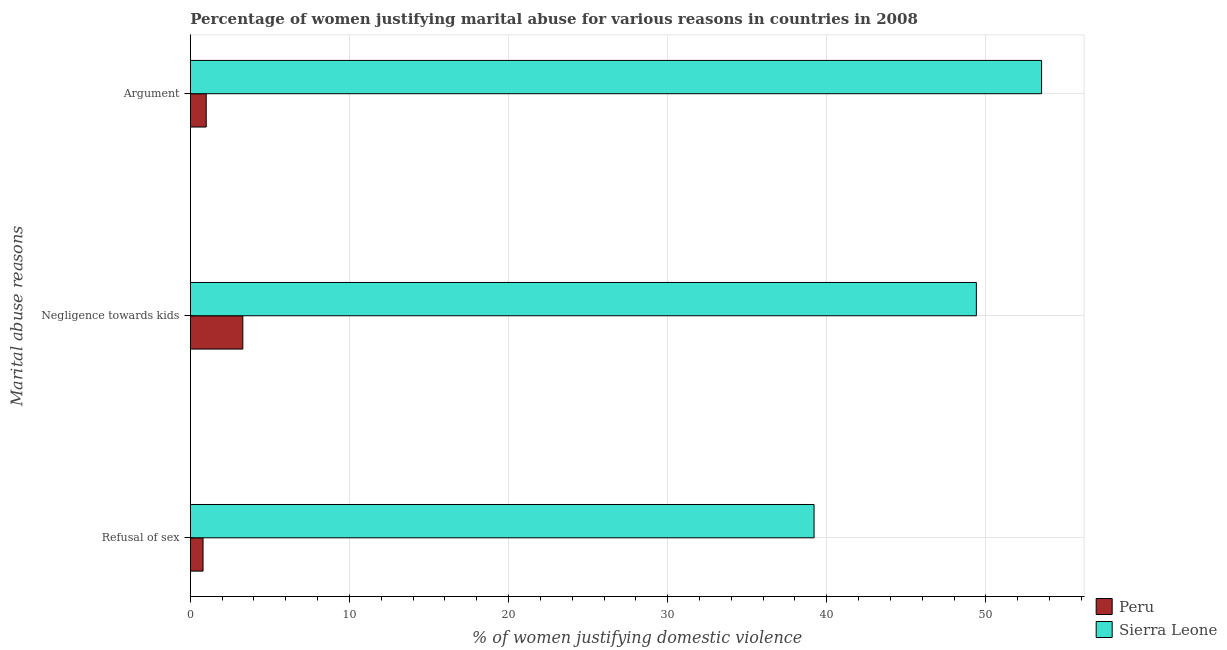What is the label of the 3rd group of bars from the top?
Provide a succinct answer. Refusal of sex. What is the percentage of women justifying domestic violence due to arguments in Sierra Leone?
Provide a succinct answer. 53.5. Across all countries, what is the maximum percentage of women justifying domestic violence due to arguments?
Provide a short and direct response. 53.5. Across all countries, what is the minimum percentage of women justifying domestic violence due to negligence towards kids?
Your response must be concise. 3.3. In which country was the percentage of women justifying domestic violence due to arguments maximum?
Offer a terse response. Sierra Leone. What is the difference between the percentage of women justifying domestic violence due to refusal of sex in Sierra Leone and that in Peru?
Your answer should be very brief. 38.4. What is the difference between the percentage of women justifying domestic violence due to negligence towards kids in Sierra Leone and the percentage of women justifying domestic violence due to refusal of sex in Peru?
Provide a short and direct response. 48.6. What is the average percentage of women justifying domestic violence due to arguments per country?
Provide a short and direct response. 27.25. What is the difference between the percentage of women justifying domestic violence due to negligence towards kids and percentage of women justifying domestic violence due to refusal of sex in Peru?
Offer a terse response. 2.5. In how many countries, is the percentage of women justifying domestic violence due to arguments greater than 54 %?
Offer a terse response. 0. What is the ratio of the percentage of women justifying domestic violence due to arguments in Sierra Leone to that in Peru?
Your answer should be compact. 53.5. Is the difference between the percentage of women justifying domestic violence due to refusal of sex in Peru and Sierra Leone greater than the difference between the percentage of women justifying domestic violence due to arguments in Peru and Sierra Leone?
Your answer should be compact. Yes. What is the difference between the highest and the second highest percentage of women justifying domestic violence due to refusal of sex?
Offer a very short reply. 38.4. What is the difference between the highest and the lowest percentage of women justifying domestic violence due to refusal of sex?
Offer a very short reply. 38.4. What does the 1st bar from the bottom in Negligence towards kids represents?
Provide a short and direct response. Peru. Are all the bars in the graph horizontal?
Ensure brevity in your answer.  Yes. What is the difference between two consecutive major ticks on the X-axis?
Make the answer very short. 10. Are the values on the major ticks of X-axis written in scientific E-notation?
Provide a succinct answer. No. Does the graph contain any zero values?
Provide a succinct answer. No. Where does the legend appear in the graph?
Ensure brevity in your answer.  Bottom right. How many legend labels are there?
Give a very brief answer. 2. What is the title of the graph?
Your answer should be compact. Percentage of women justifying marital abuse for various reasons in countries in 2008. Does "Yemen, Rep." appear as one of the legend labels in the graph?
Offer a terse response. No. What is the label or title of the X-axis?
Offer a very short reply. % of women justifying domestic violence. What is the label or title of the Y-axis?
Give a very brief answer. Marital abuse reasons. What is the % of women justifying domestic violence in Peru in Refusal of sex?
Make the answer very short. 0.8. What is the % of women justifying domestic violence in Sierra Leone in Refusal of sex?
Offer a terse response. 39.2. What is the % of women justifying domestic violence in Sierra Leone in Negligence towards kids?
Give a very brief answer. 49.4. What is the % of women justifying domestic violence of Sierra Leone in Argument?
Your answer should be very brief. 53.5. Across all Marital abuse reasons, what is the maximum % of women justifying domestic violence of Peru?
Make the answer very short. 3.3. Across all Marital abuse reasons, what is the maximum % of women justifying domestic violence of Sierra Leone?
Make the answer very short. 53.5. Across all Marital abuse reasons, what is the minimum % of women justifying domestic violence of Peru?
Ensure brevity in your answer.  0.8. Across all Marital abuse reasons, what is the minimum % of women justifying domestic violence of Sierra Leone?
Your response must be concise. 39.2. What is the total % of women justifying domestic violence in Peru in the graph?
Your answer should be compact. 5.1. What is the total % of women justifying domestic violence of Sierra Leone in the graph?
Give a very brief answer. 142.1. What is the difference between the % of women justifying domestic violence of Sierra Leone in Refusal of sex and that in Negligence towards kids?
Provide a short and direct response. -10.2. What is the difference between the % of women justifying domestic violence of Sierra Leone in Refusal of sex and that in Argument?
Give a very brief answer. -14.3. What is the difference between the % of women justifying domestic violence of Peru in Negligence towards kids and that in Argument?
Provide a short and direct response. 2.3. What is the difference between the % of women justifying domestic violence of Sierra Leone in Negligence towards kids and that in Argument?
Provide a short and direct response. -4.1. What is the difference between the % of women justifying domestic violence of Peru in Refusal of sex and the % of women justifying domestic violence of Sierra Leone in Negligence towards kids?
Give a very brief answer. -48.6. What is the difference between the % of women justifying domestic violence of Peru in Refusal of sex and the % of women justifying domestic violence of Sierra Leone in Argument?
Provide a succinct answer. -52.7. What is the difference between the % of women justifying domestic violence of Peru in Negligence towards kids and the % of women justifying domestic violence of Sierra Leone in Argument?
Offer a very short reply. -50.2. What is the average % of women justifying domestic violence of Sierra Leone per Marital abuse reasons?
Your answer should be very brief. 47.37. What is the difference between the % of women justifying domestic violence in Peru and % of women justifying domestic violence in Sierra Leone in Refusal of sex?
Your answer should be compact. -38.4. What is the difference between the % of women justifying domestic violence in Peru and % of women justifying domestic violence in Sierra Leone in Negligence towards kids?
Your response must be concise. -46.1. What is the difference between the % of women justifying domestic violence in Peru and % of women justifying domestic violence in Sierra Leone in Argument?
Provide a succinct answer. -52.5. What is the ratio of the % of women justifying domestic violence of Peru in Refusal of sex to that in Negligence towards kids?
Your answer should be compact. 0.24. What is the ratio of the % of women justifying domestic violence of Sierra Leone in Refusal of sex to that in Negligence towards kids?
Your answer should be very brief. 0.79. What is the ratio of the % of women justifying domestic violence of Sierra Leone in Refusal of sex to that in Argument?
Offer a terse response. 0.73. What is the ratio of the % of women justifying domestic violence in Sierra Leone in Negligence towards kids to that in Argument?
Ensure brevity in your answer.  0.92. What is the difference between the highest and the second highest % of women justifying domestic violence in Peru?
Give a very brief answer. 2.3. What is the difference between the highest and the second highest % of women justifying domestic violence of Sierra Leone?
Your response must be concise. 4.1. What is the difference between the highest and the lowest % of women justifying domestic violence of Peru?
Your response must be concise. 2.5. 